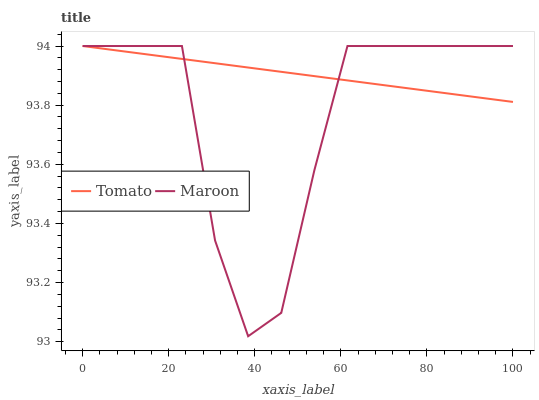Does Maroon have the maximum area under the curve?
Answer yes or no. No. Is Maroon the smoothest?
Answer yes or no. No. 